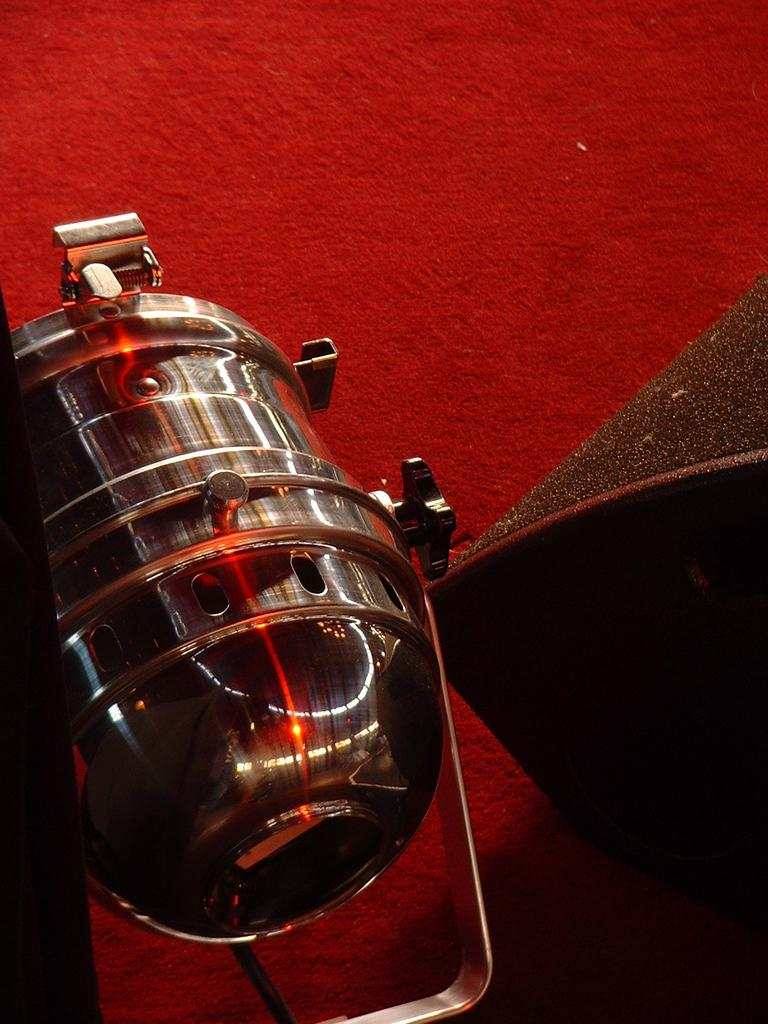What is the color of the carpet in the image? The carpet in the image is red. Can you describe any objects present in the image? Unfortunately, the provided facts do not specify any objects present in the image. What type of chin is visible on the feather in the image? There is no chin or feather present in the image; it only features a red carpet. 